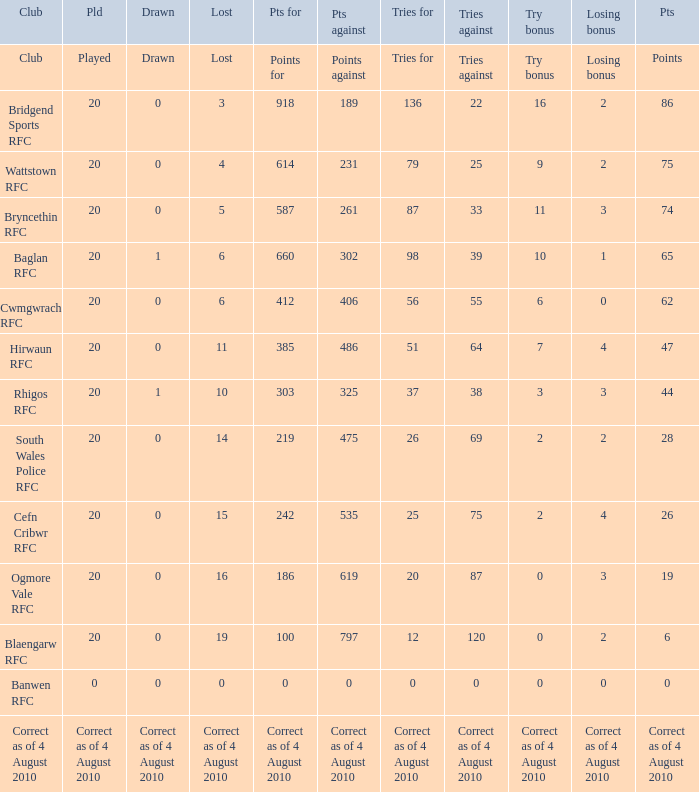What is the points against when the losing bonus is 0 and the club is banwen rfc? 0.0. 